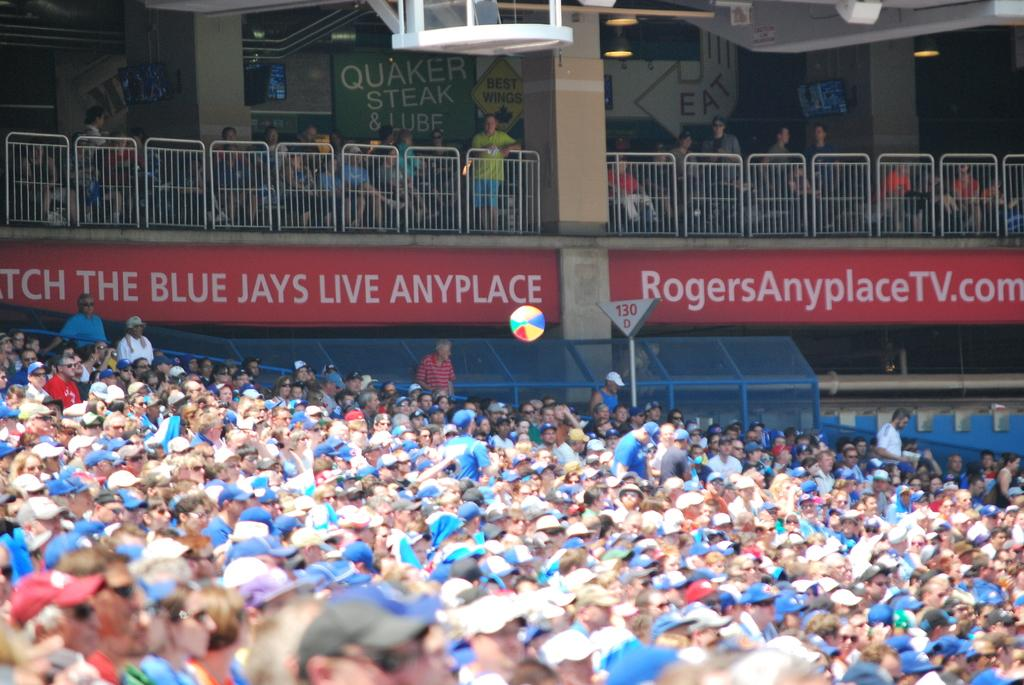What are the people in the image doing? There are people sitting on chairs and standing on the floor in the image. Where is the setting of the image? The setting is a stadium. What can be seen illuminating the area in the image? Electric lights are visible in the image. What safety feature is present in the image? Railings are present in the image. What can be used for providing information in the image? Information boards are present in the image. What type of toothpaste is being advertised on the fireman's uniform in the image? There is no fireman or toothpaste advertisement present in the image. How many people are celebrating the birth of a new family member in the image? There is no indication of a birth or celebration in the image. 